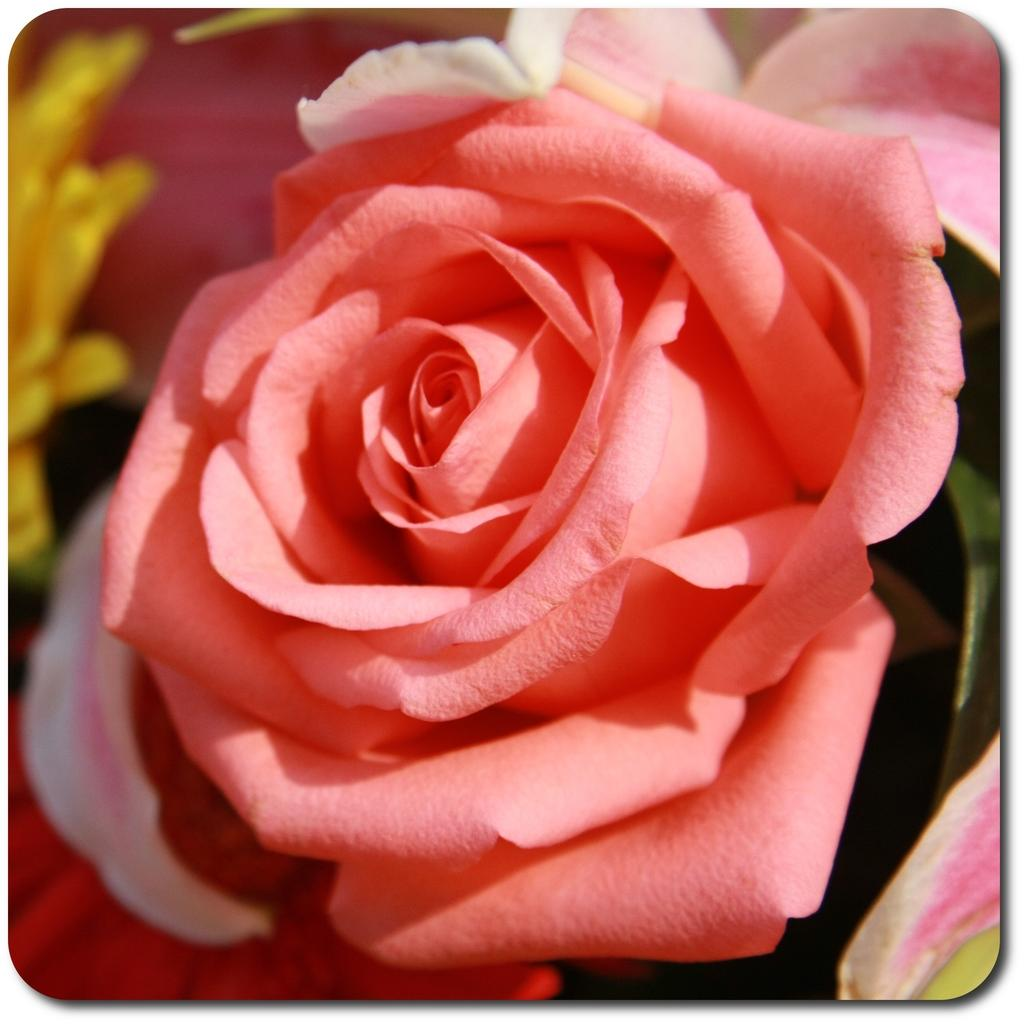What type of image is being described? The image is a photo. What can be seen in the photo? There are flowers in the image. What type of music is the band playing in the background of the photo? There is no band present in the photo, as the image only features flowers. 